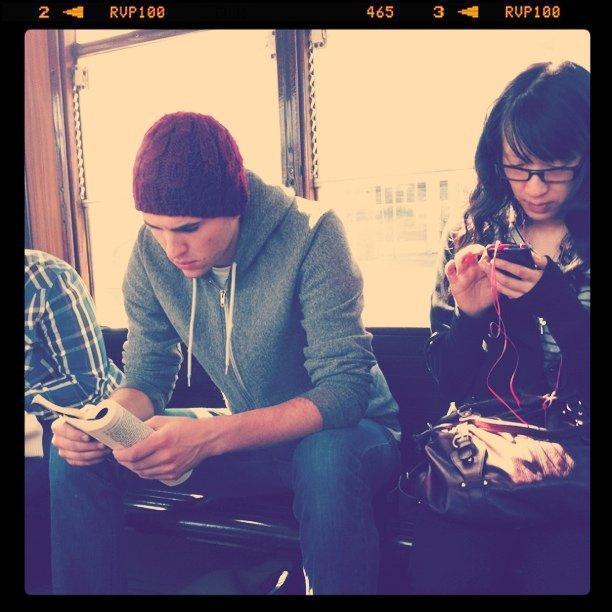How many men are wearing glasses?
Give a very brief answer. 0. How many people are in the college?
Give a very brief answer. 3. How many people are wearing hats?
Give a very brief answer. 1. How many people are there?
Give a very brief answer. 3. How many books can you see?
Give a very brief answer. 1. 